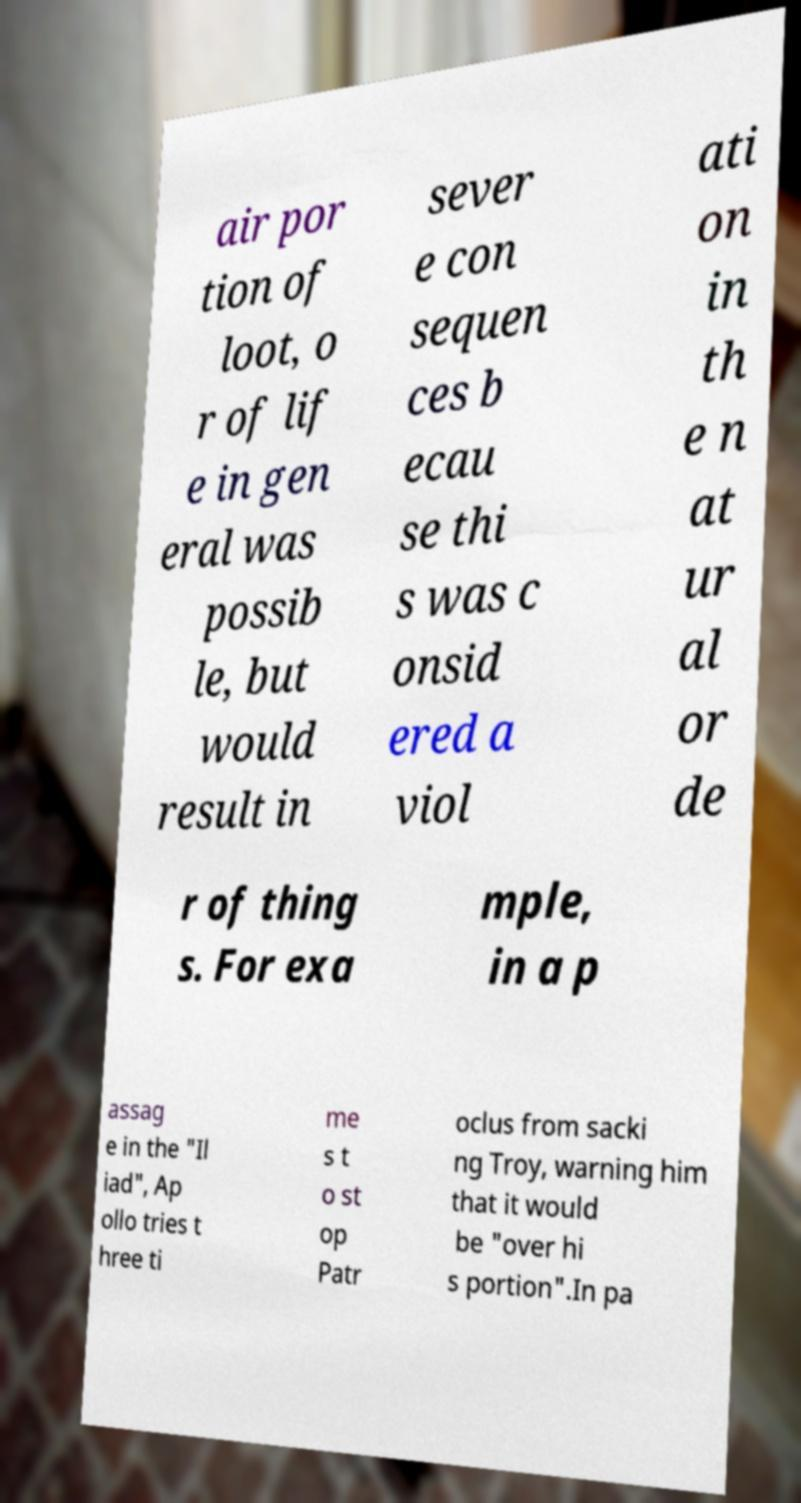Please read and relay the text visible in this image. What does it say? air por tion of loot, o r of lif e in gen eral was possib le, but would result in sever e con sequen ces b ecau se thi s was c onsid ered a viol ati on in th e n at ur al or de r of thing s. For exa mple, in a p assag e in the "Il iad", Ap ollo tries t hree ti me s t o st op Patr oclus from sacki ng Troy, warning him that it would be "over hi s portion".In pa 